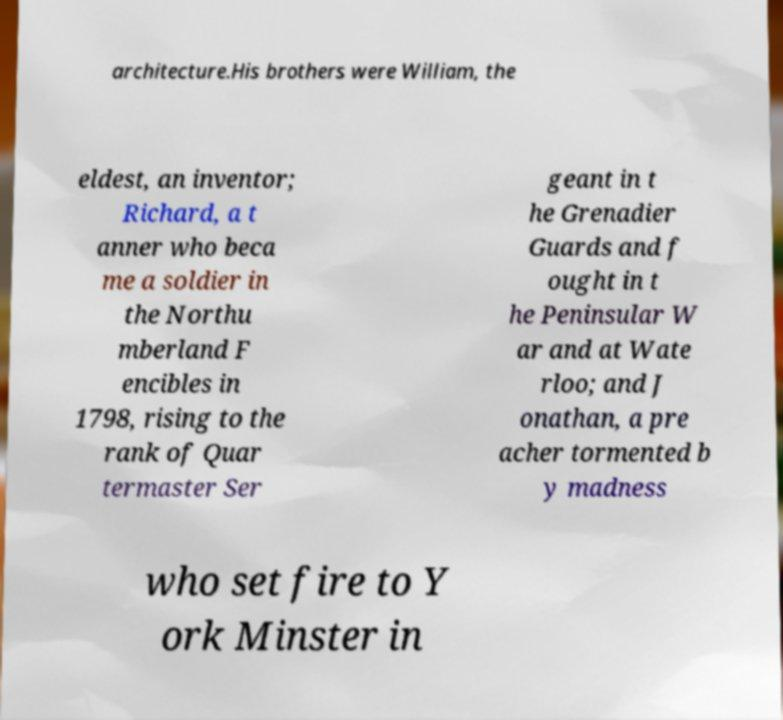Please read and relay the text visible in this image. What does it say? architecture.His brothers were William, the eldest, an inventor; Richard, a t anner who beca me a soldier in the Northu mberland F encibles in 1798, rising to the rank of Quar termaster Ser geant in t he Grenadier Guards and f ought in t he Peninsular W ar and at Wate rloo; and J onathan, a pre acher tormented b y madness who set fire to Y ork Minster in 